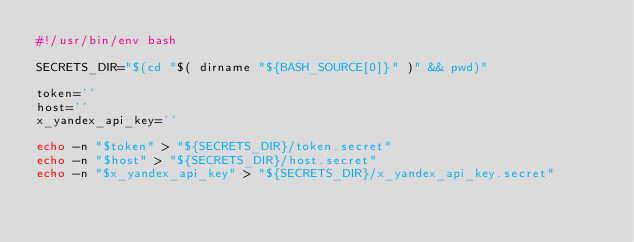Convert code to text. <code><loc_0><loc_0><loc_500><loc_500><_Bash_>#!/usr/bin/env bash

SECRETS_DIR="$(cd "$( dirname "${BASH_SOURCE[0]}" )" && pwd)"

token=''
host=''
x_yandex_api_key=''

echo -n "$token" > "${SECRETS_DIR}/token.secret"
echo -n "$host" > "${SECRETS_DIR}/host.secret"
echo -n "$x_yandex_api_key" > "${SECRETS_DIR}/x_yandex_api_key.secret"
</code> 